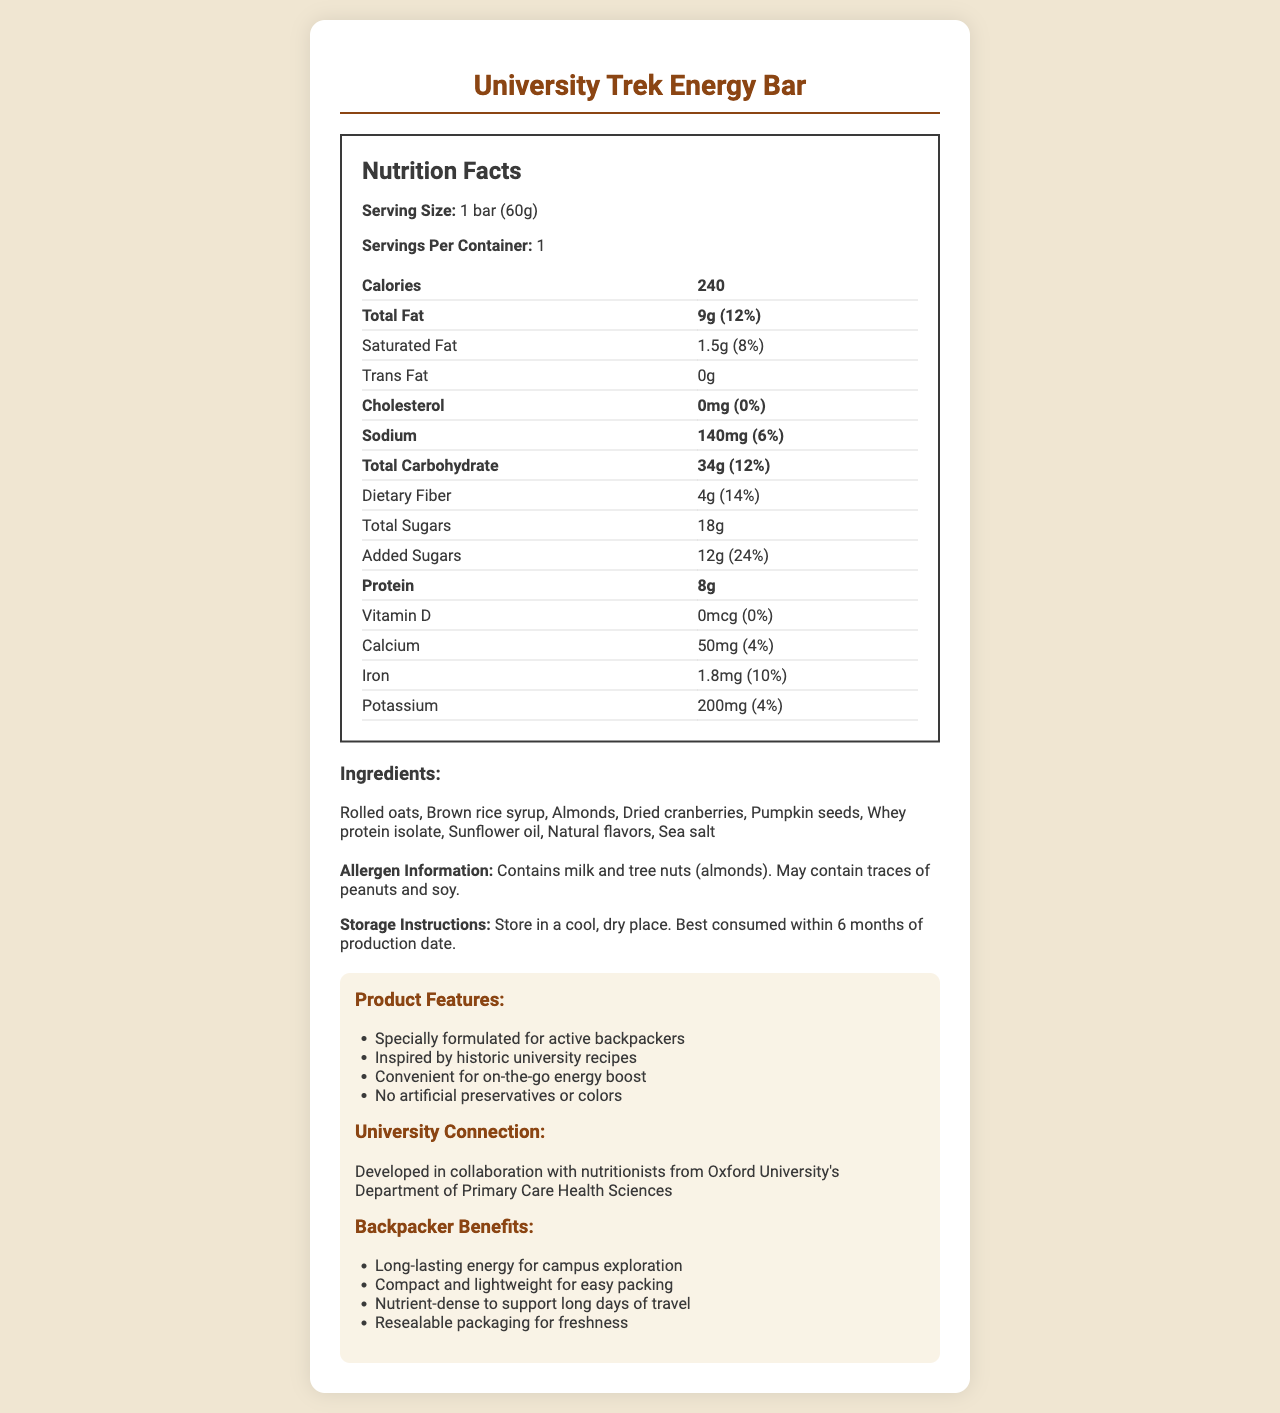what is the serving size of the University Trek Energy Bar? The serving size is explicitly mentioned as "1 bar (60g)" in the nutrition facts section of the document.
Answer: 1 bar (60g) how many calories are in one serving? The calories per serving are listed as 240 in the main nutrition facts information.
Answer: 240 what is the daily value percentage of dietary fiber? The daily value percentage for dietary fiber is given as 14% next to the fiber content in the nutrition table.
Answer: 14% how much protein does the University Trek Energy Bar contain? The protein content is mentioned as 8g in the nutrition facts section.
Answer: 8g what are the main ingredients of the University Trek Energy Bar? These ingredients are listed in the "Ingredients" section of the document.
Answer: Rolled oats, Brown rice syrup, Almonds, Dried cranberries, Pumpkin seeds, Whey protein isolate, Sunflower oil, Natural flavors, Sea salt which feature is specially formulated for active backpackers? A. No artificial preservatives or colors B. Long-lasting energy for campus exploration C. Specially formulated for active backpackers This feature is listed under "Product Features" with the exact wording "Specially formulated for active backpackers."
Answer: C. Specially formulated for active backpackers what is the percentage of daily value for added sugars? A. 8% B. 14% C. 24% D. 6% The document mentions the daily value of added sugars as 24% in the nutrition facts section.
Answer: C. 24% does the University Trek Energy Bar contain any trans fat? The nutrition facts state that the trans fat content is 0g, indicating there is no trans fat.
Answer: No was the energy bar developed in collaboration with a university? The document specifies that the energy bar was developed in collaboration with nutritionists from Oxford University's Department of Primary Care Health Sciences.
Answer: Yes summarize the main idea of the document. The document offers a comprehensive overview of the University Trek Energy Bar, emphasizing its nutritional benefits, development background, and suitability for backpackers, along with specific product features and storage guidelines.
Answer: The document provides detailed nutritional information for the University Trek Energy Bar, including serving size, calorie content, and percentages of daily values for various nutrients. It also lists the ingredients, allergen information, and storage instructions. Additionally, it highlights the product features, university collaboration, and benefits for backpackers. what is the production date of the energy bar? The document does not provide the production date of the energy bar, so this information can't be determined.
Answer: Not enough information what amount of calcium does one serving provide? The document lists the calcium content as 50mg in the nutrition facts section.
Answer: 50mg 